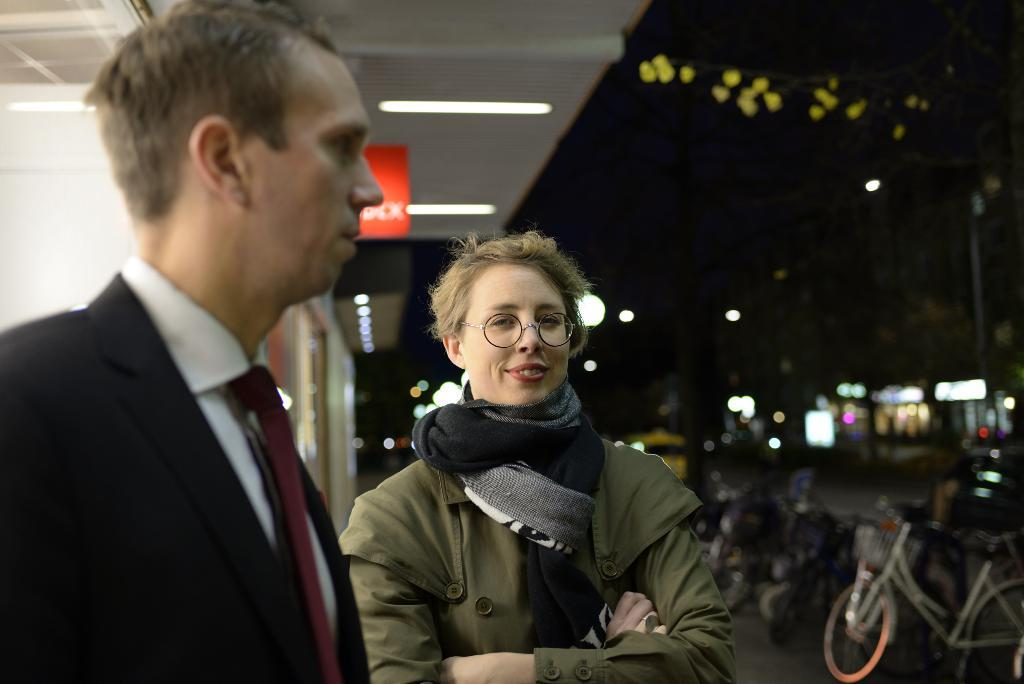How many people are in the image? There are two people in the image, a man and a woman. What are the man and woman doing in the image? The man and woman are standing. What can be seen on the right side of the image? There are bicycles on the right side of the image. What else is visible in the image besides the people and bicycles? There are lights visible in the image. What channel is the man watching on the television in the image? There is no television present in the image, so it is not possible to determine what channel the man might be watching. 